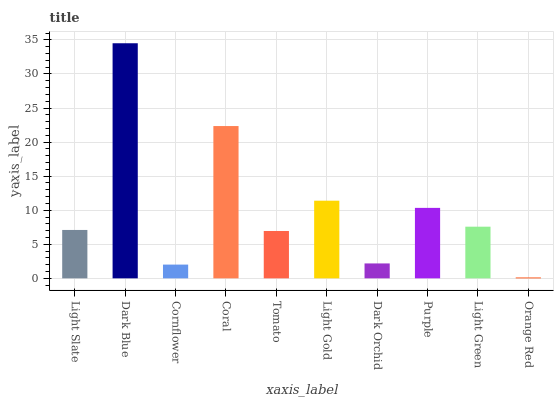Is Cornflower the minimum?
Answer yes or no. No. Is Cornflower the maximum?
Answer yes or no. No. Is Dark Blue greater than Cornflower?
Answer yes or no. Yes. Is Cornflower less than Dark Blue?
Answer yes or no. Yes. Is Cornflower greater than Dark Blue?
Answer yes or no. No. Is Dark Blue less than Cornflower?
Answer yes or no. No. Is Light Green the high median?
Answer yes or no. Yes. Is Light Slate the low median?
Answer yes or no. Yes. Is Coral the high median?
Answer yes or no. No. Is Light Green the low median?
Answer yes or no. No. 